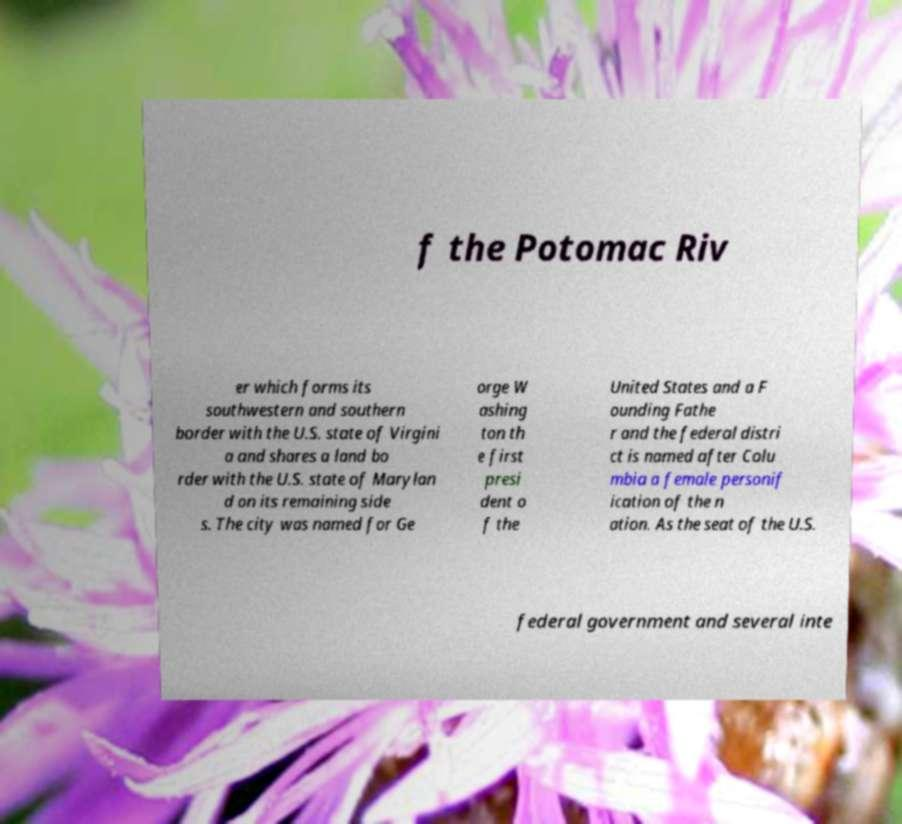I need the written content from this picture converted into text. Can you do that? f the Potomac Riv er which forms its southwestern and southern border with the U.S. state of Virgini a and shares a land bo rder with the U.S. state of Marylan d on its remaining side s. The city was named for Ge orge W ashing ton th e first presi dent o f the United States and a F ounding Fathe r and the federal distri ct is named after Colu mbia a female personif ication of the n ation. As the seat of the U.S. federal government and several inte 